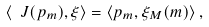Convert formula to latex. <formula><loc_0><loc_0><loc_500><loc_500>\left \langle \ J ( p _ { m } ) , \xi \right \rangle = \left \langle p _ { m } , \xi _ { M } ( m ) \right \rangle ,</formula> 